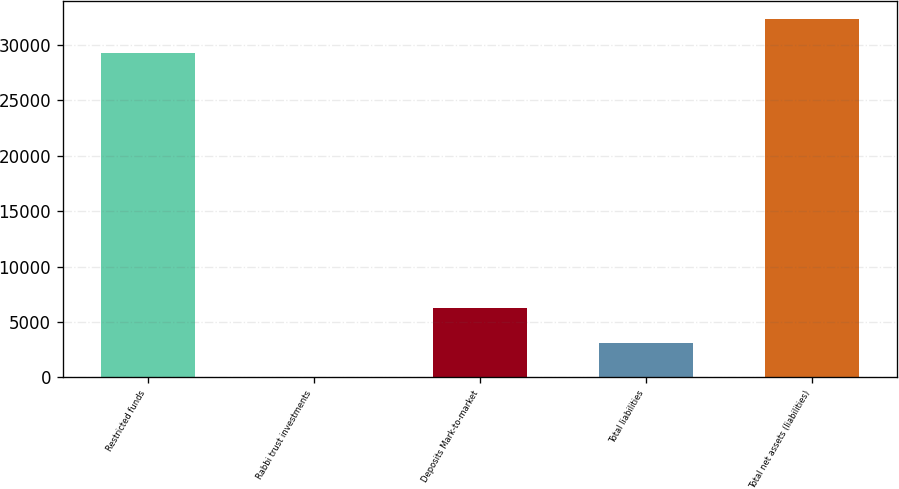<chart> <loc_0><loc_0><loc_500><loc_500><bar_chart><fcel>Restricted funds<fcel>Rabbi trust investments<fcel>Deposits Mark-to-market<fcel>Total liabilities<fcel>Total net assets (liabilities)<nl><fcel>29259<fcel>0.6<fcel>6232.48<fcel>3116.54<fcel>32374.9<nl></chart> 